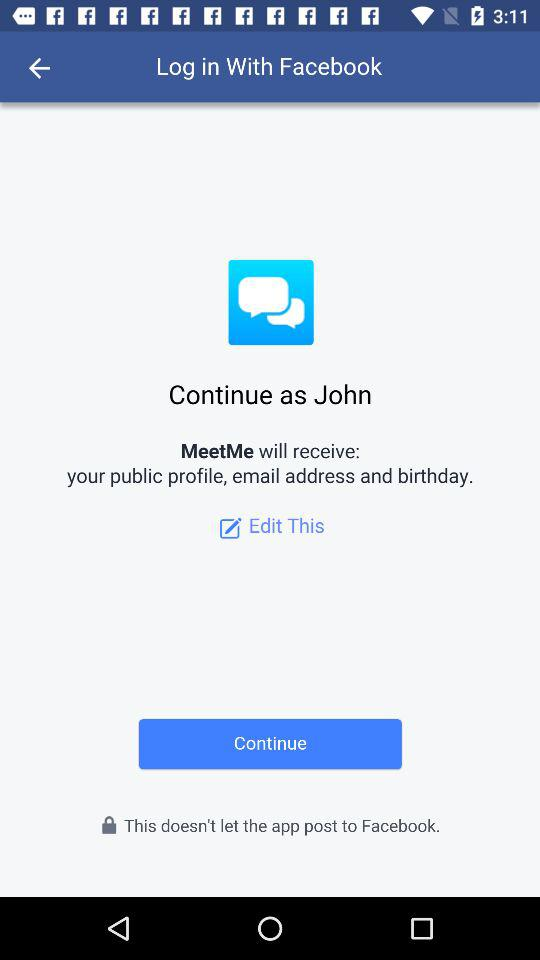How can we log in? You can log in with "Facebook". 